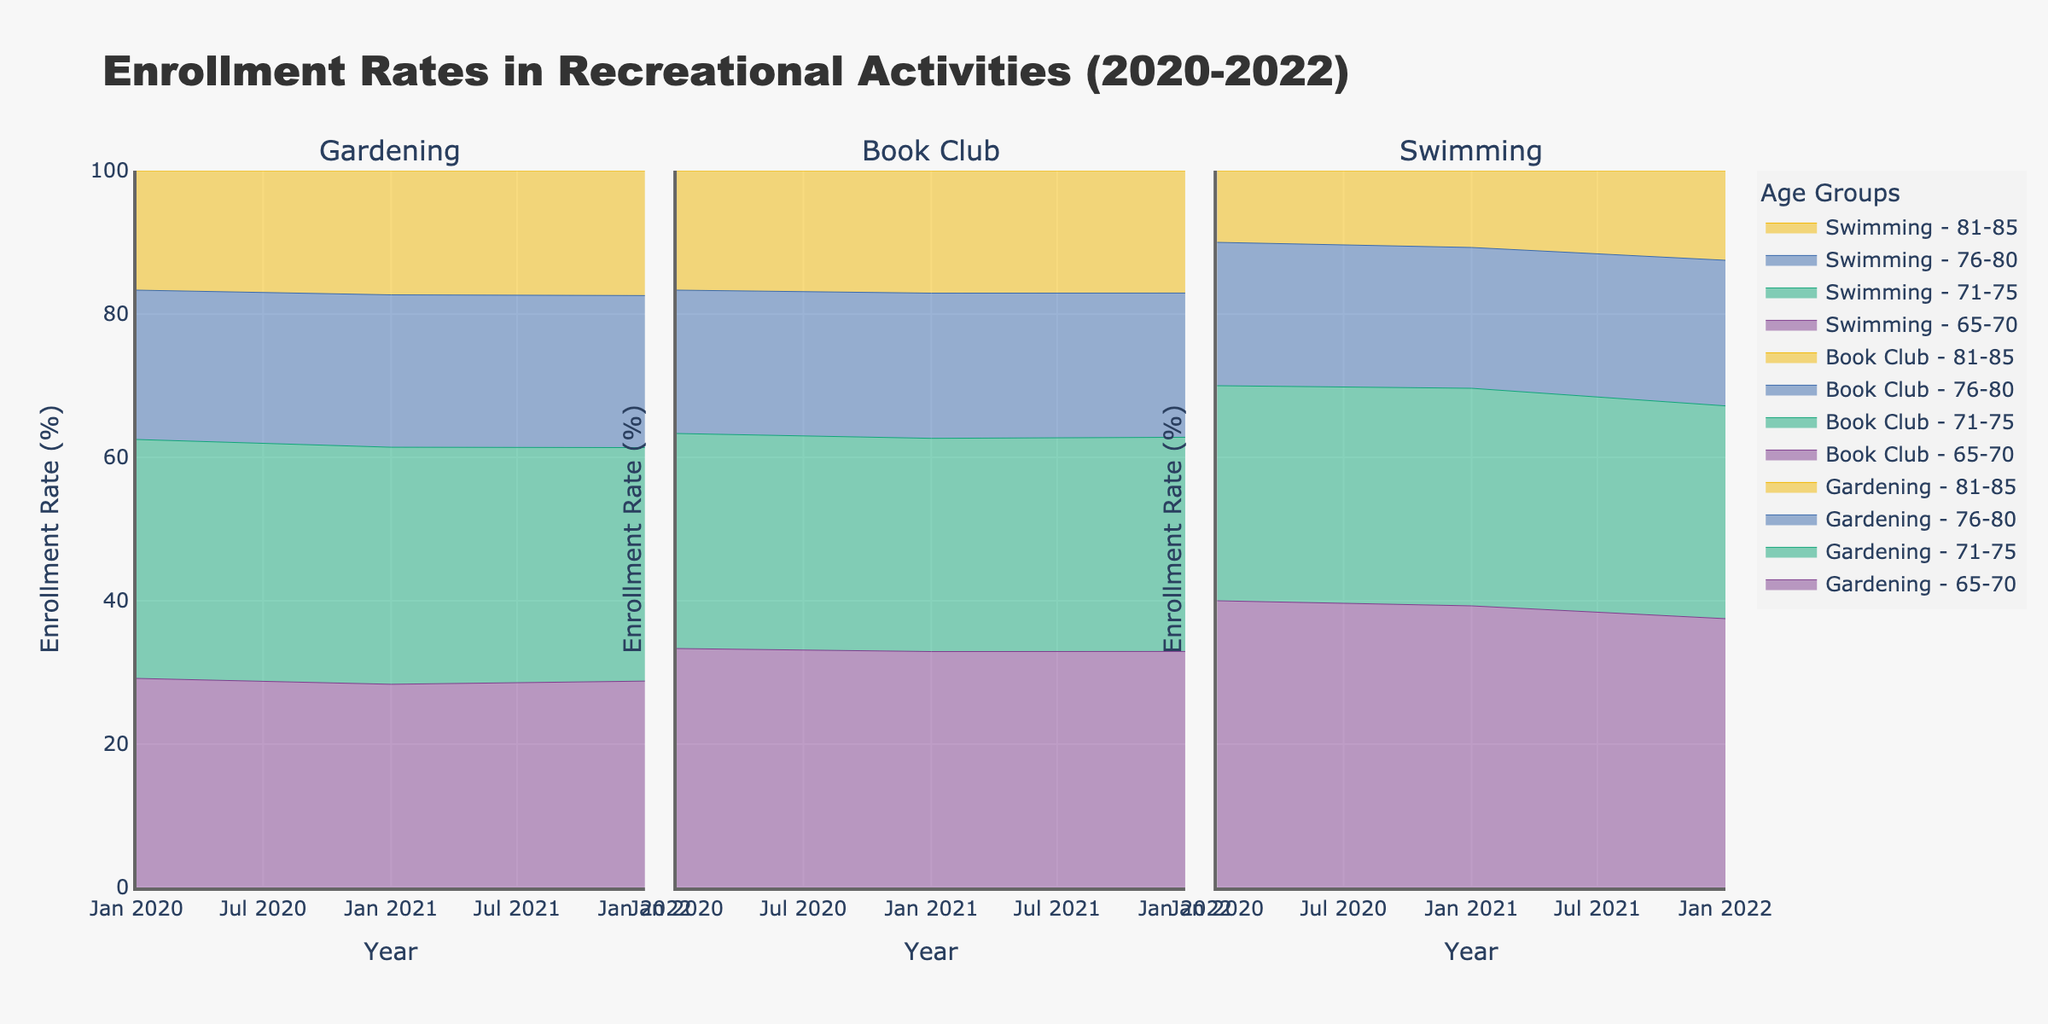What is the title of the chart? The title of the chart is displayed at the top and reads "Enrollment Rates in Recreational Activities (2020-2022)"
Answer: Enrollment Rates in Recreational Activities (2020-2022) Which age group shows the highest enrollment rate for the Gardening activity in 2022? By looking at the subplots under Gardening for the year 2022, we see that the 71-75 age group has the highest enrollment rate compared to other age groups
Answer: 71-75 What is the range of the y-axis in this chart? The y-axis range for all the activities subplots is marked from 0% to 100%
Answer: 0% to 100% How does the enrollment rate for Book Club for the 65-70 age group change from 2020 to 2022? In the Book Club subplot, follow the line for the 65-70 age group from 2020 to 2022. It shows a gradual increase from 50% in 2020 to 54% in 2022
Answer: Increases by 4% Which activity has the lowest overall enrollment rate for all age groups in 2020? Compare the bottom areas of all subplots for the year 2020. Swimming has the smallest stacked area, indicating the lowest overall enrollment rate
Answer: Swimming Compare the enrollment rates for Swimming and Gardening for the age group 76-80 in 2020. Which one is higher and by how much? Look at the subplots for Swimming and Gardening for 2020. The 76-80 age group has a 25% enrollment rate in Gardening and a 10% rate in Swimming. Subtract 10% from 25%
Answer: Gardening is higher by 15% Did the enrollment rate for the 81-85 age group in the Book Club increase or decrease from 2020 to 2022? Refer to the Book Club subplot and trace the line for the 81-85 age group from 2020 to 2022. It increased from 25% to 28%
Answer: Increased What is the average enrollment rate for the 65-70 age group across all activities in 2021? Find the 65-70 age group's enrollment rates in 2021 for Gardening (36%), Book Club (52%), and Swimming (22%). Calculate the average: (36 + 52 + 22) / 3 = 110 / 3 = 36.67%
Answer: 36.67% Which age group in the Book Club has the smallest change in enrollment rates from 2020 to 2022? Check the Book Club subplot and compare the change for each age group from 2020 to 2022. The 81-85 age group changes minimally from 25% to 28%. Other age groups have a larger increase
Answer: 81-85 